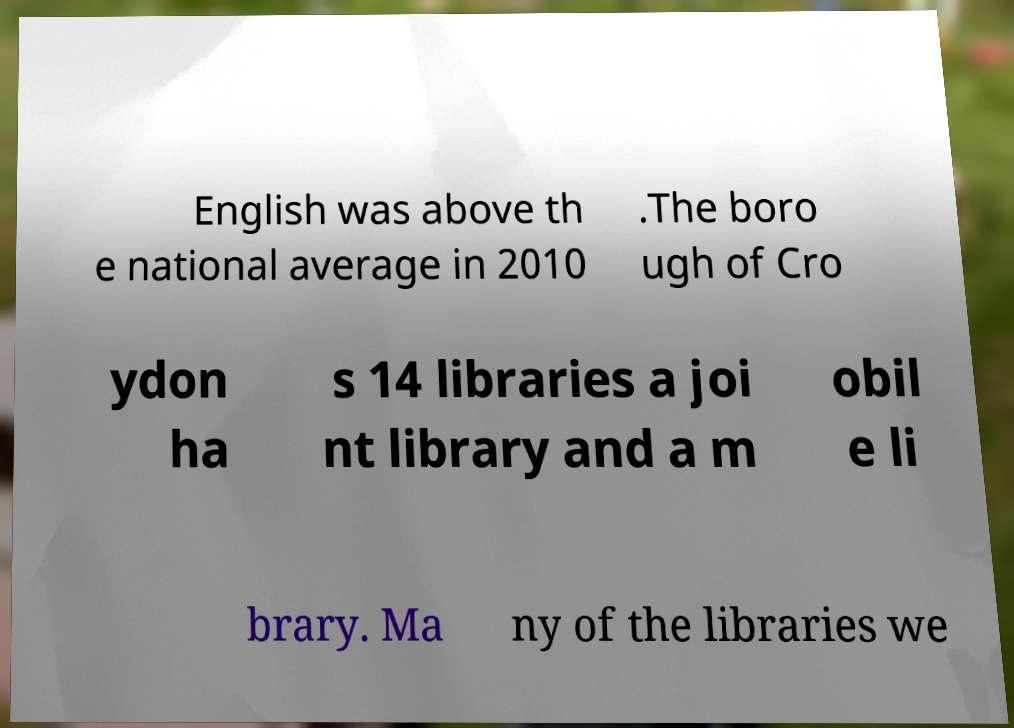Can you accurately transcribe the text from the provided image for me? English was above th e national average in 2010 .The boro ugh of Cro ydon ha s 14 libraries a joi nt library and a m obil e li brary. Ma ny of the libraries we 